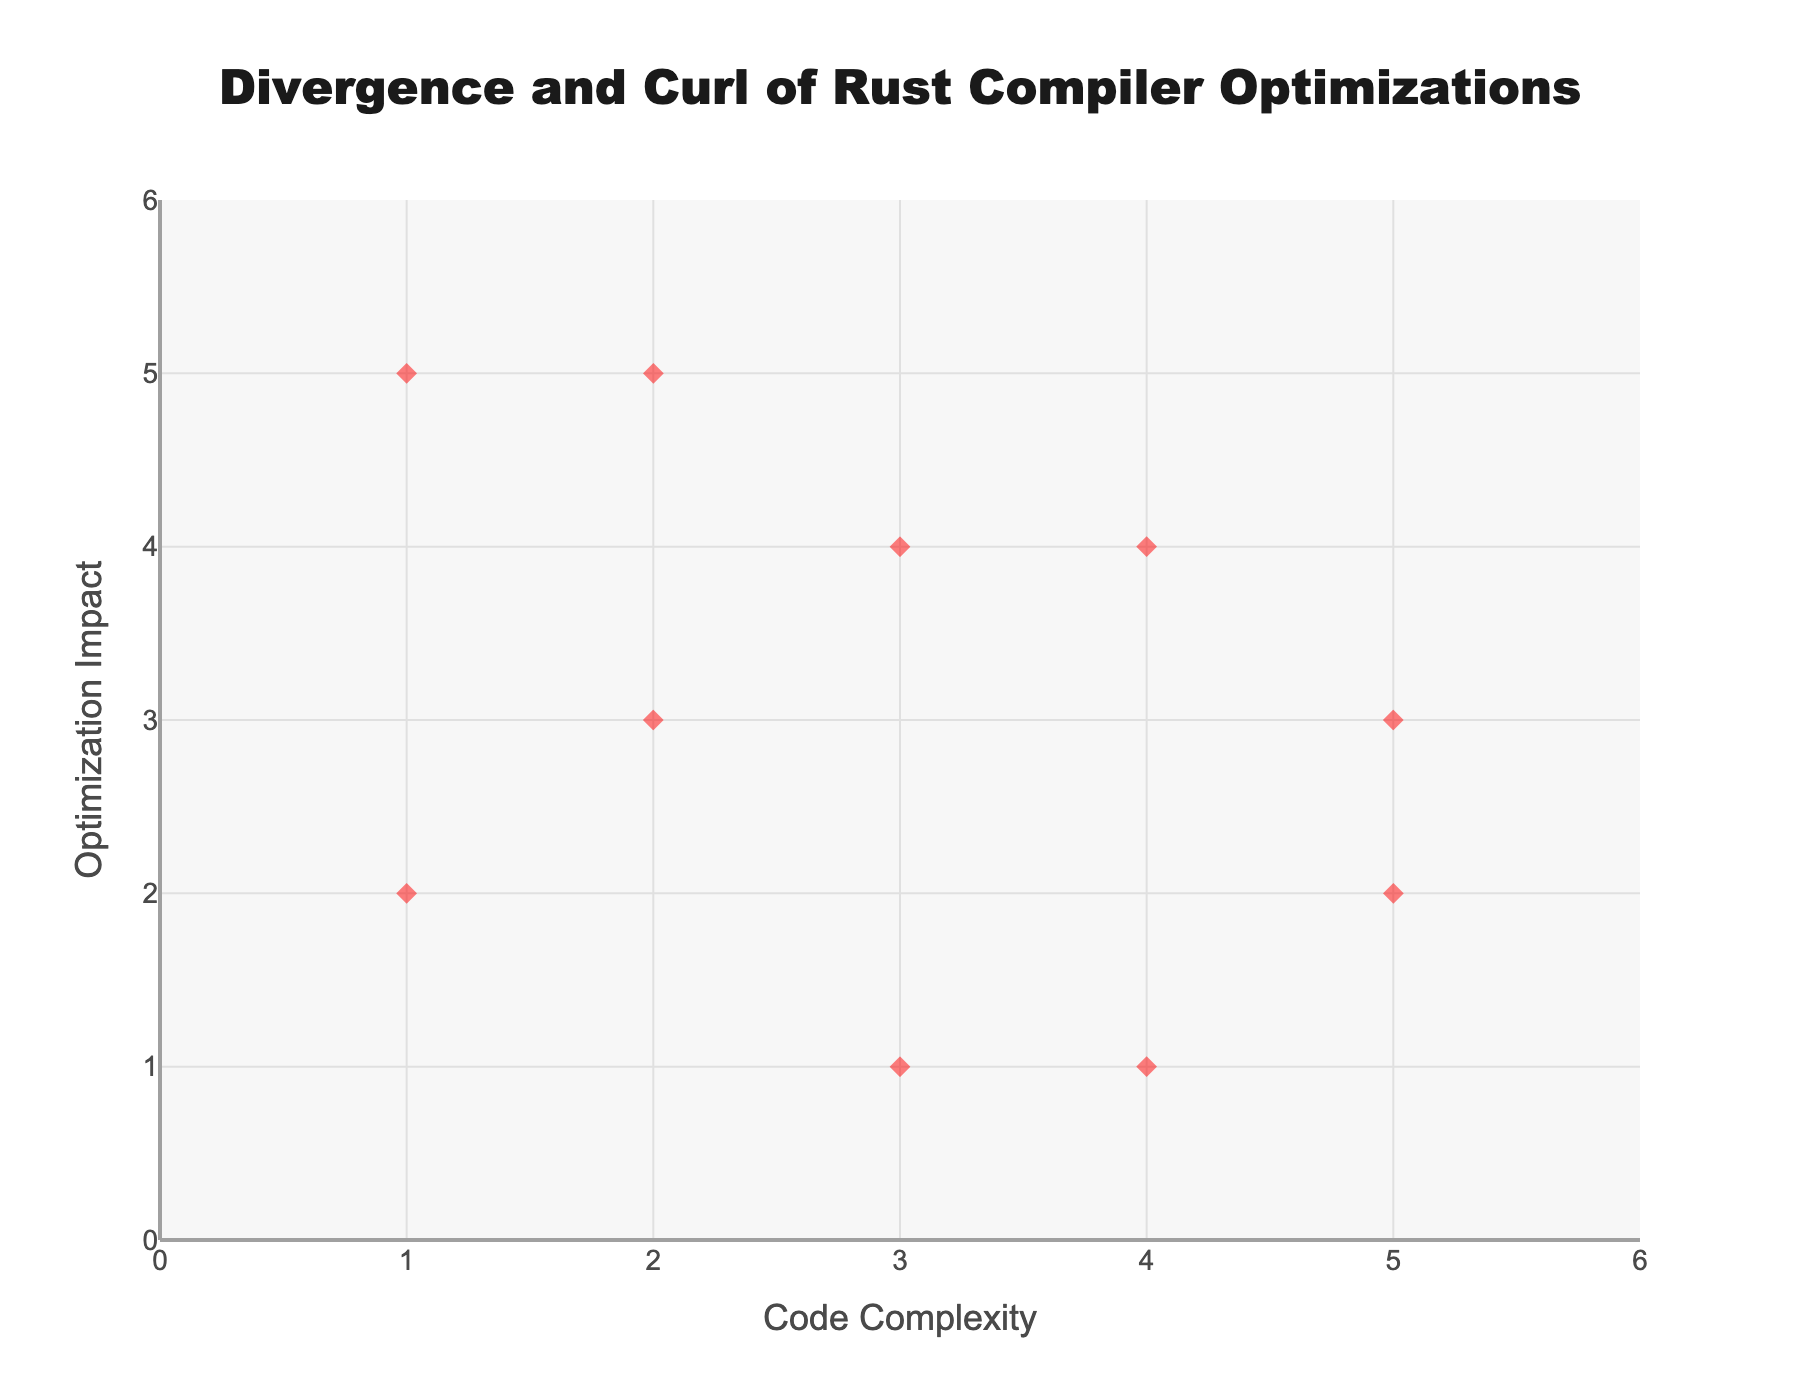What is the title of the figure? The title of the figure is located at the top, usually centered, and it gives an overview of the content or context of the visualization. Here, the title is "Divergence and Curl of Rust Compiler Optimizations" as noted in the code layout settings.
Answer: Divergence and Curl of Rust Compiler Optimizations How many data points are there in the figure? To find the number of data points, you can look at the number of markers in the scatter plot or the number of arrows in the quiver plot. Each marker and arrow represent a data point. According to the data provided, there are 10 data points.
Answer: 10 Which optimization has the highest impact on optimization impact y-coordinate? To find this, we look for the highest y-coordinate value among the optimization points on the y-axis. From the data provided, "Tail call optimization" has a y-coordinate value of 5, which is the highest.
Answer: Tail call optimization Which optimization has the most negative impact on the divergence (u component) in the plot? To determine this, we look for the most negative u component in the quiver plot. We see that "Bounds check elimination" has a u component of -0.5, which is the most negative value in the dataset.
Answer: Bounds check elimination What are the x and y coordinates for the optimization with a u component of 0.4? To find this, we locate the optimization with a u component of 0.4 in the data. "Constant folding" has a u component of 0.4, and its coordinates are (3, 1).
Answer: 3, 1 How is the "Function specialization" optimization vector oriented compared to "Strength reduction"? We compare the vector components (u,v) of both optimizations. "Function specialization" has (0.2,-0.2) and "Strength reduction" has (0.1,0.5). The former points slightly rightward and downward, while the latter points slightly rightward and upward.
Answer: Function specialization: points slightly rightward and downward; Strength reduction: points slightly rightward and upward Among the optimizations with a negative v component, which one has the highest x-coordinate? First, identify the optimizations with a negative v component: "Inlining", "Function specialization", and "Bounds check elimination". Among these, the one with the highest x-coordinate is "Bounds check elimination" with an x-coordinate of 5.
Answer: Bounds check elimination What is the combined u component of "SIMD vectorization" and "Dead code elimination"? To find this, sum the u components of these two optimizations: "SIMD vectorization" (-0.4) and "Dead code elimination" (-0.1). The combined u component is -0.5.
Answer: -0.5 